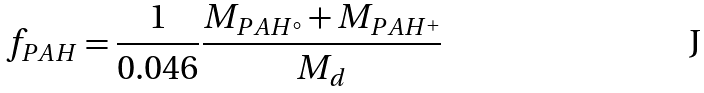Convert formula to latex. <formula><loc_0><loc_0><loc_500><loc_500>f _ { P A H } = \frac { 1 } { 0 . 0 4 6 } \frac { M _ { P A H ^ { \circ } } + M _ { P A H ^ { + } } } { M _ { d } }</formula> 